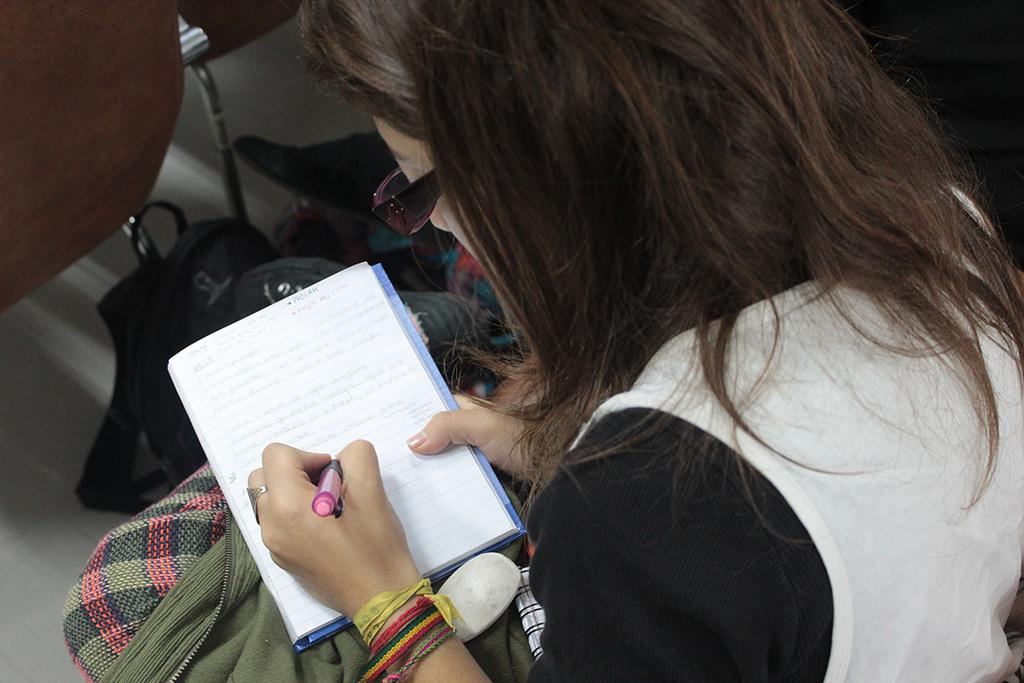Who is the main subject in the image? There is a woman in the image. What is the woman wearing on her face? The woman is wearing spectacles. What is the woman doing in the image? The woman is writing with a pen. What object is in front of the woman? There is a bag in front of the woman. What piece of furniture is in front of the woman? There is a chair in front of the woman. What type of silverware can be seen in the image? There is no silverware present in the image. 